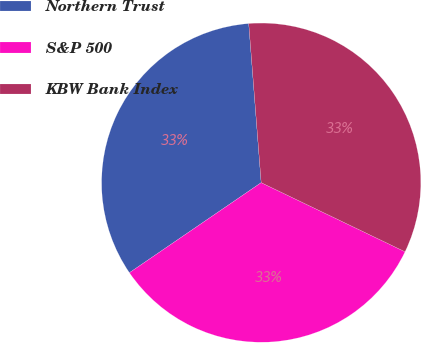Convert chart. <chart><loc_0><loc_0><loc_500><loc_500><pie_chart><fcel>Northern Trust<fcel>S&P 500<fcel>KBW Bank Index<nl><fcel>33.3%<fcel>33.33%<fcel>33.37%<nl></chart> 